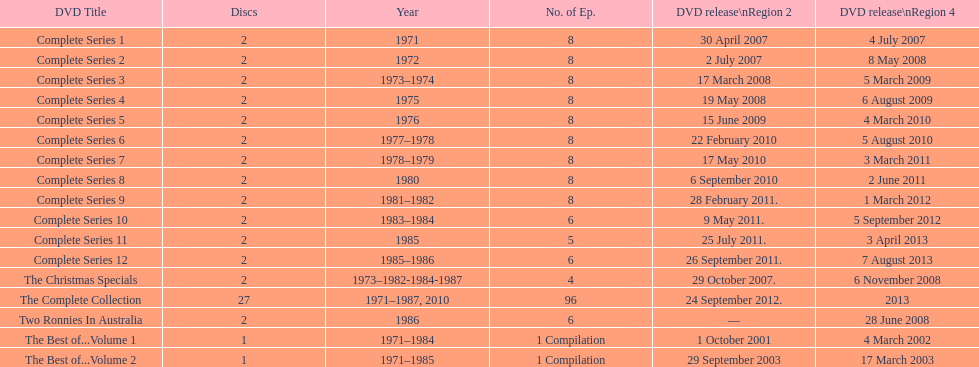Dvd shorter than 5 episodes The Christmas Specials. 